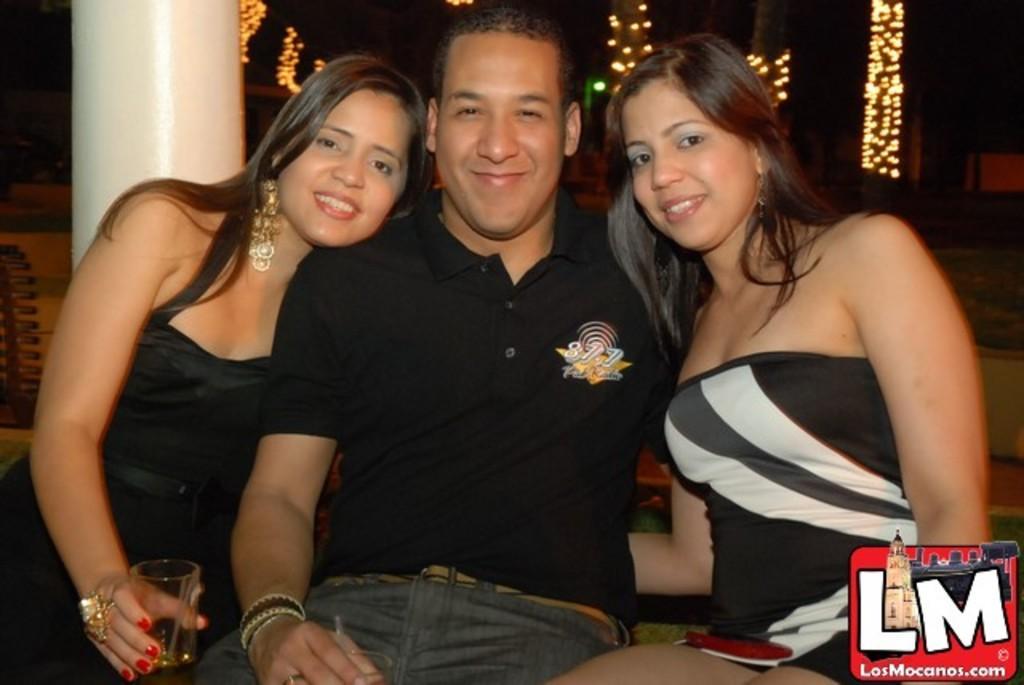How would you summarize this image in a sentence or two? This image consists of three persons. Two girls and a man. All at wearing black dress. In the background, there is a pillar. To the left, the woman sitting is holding a glass. 